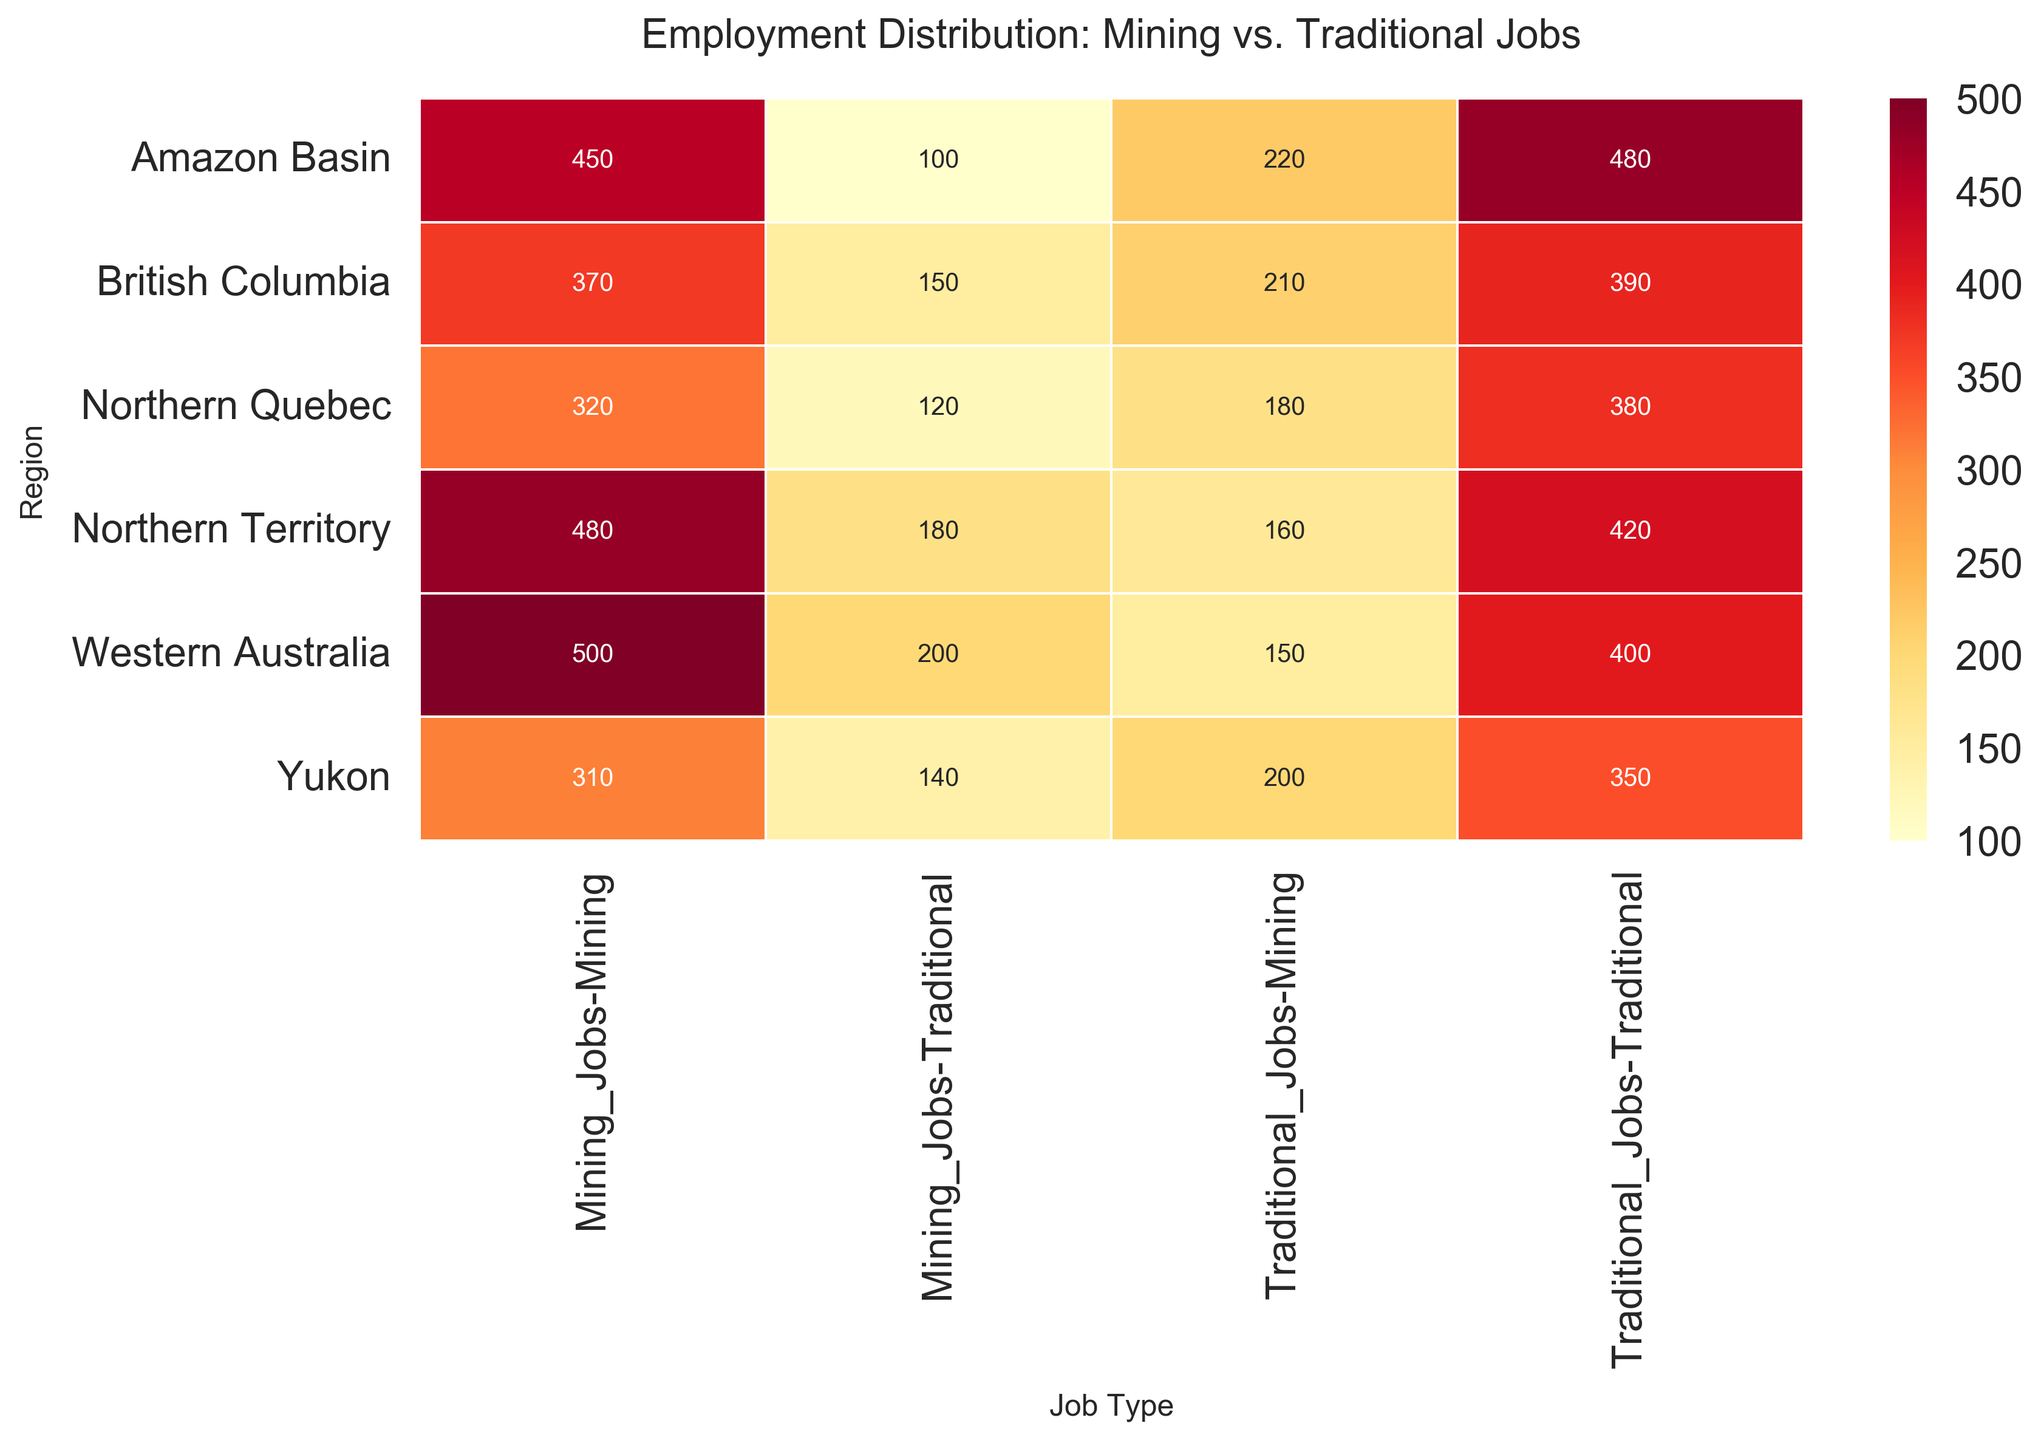What is the title of the heatmap? The title is written at the top of the heatmap.
Answer: Employment Distribution: Mining vs. Traditional Jobs Which region has the highest number of mining jobs? Look at the heatmap's cells in the Mining_Jobs column and identify the one with the highest value.
Answer: Western Australia How many traditional jobs are there in Northern Quebec? Find the cell corresponding to Northern Quebec in the Traditional_Jobs column.
Answer: 380 Compare the number of mining jobs in British Columbia and Northern Territory. Which one has more? Check the values in the Mining_Jobs column for British Columbia and Northern Territory, and compare them.
Answer: Northern Territory What is the total number of traditional jobs in the Amazon Basin and the Yukon? Add the values from the Traditional_Jobs column for the Amazon Basin and the Yukon.
Answer: 830 How does the number of traditional jobs in Northern Quebec compare to mining jobs in the same region? Compare the values in the Traditional_Jobs and Mining_Jobs columns for Northern Quebec.
Answer: Traditional jobs are more What is the average number of mining jobs across all regions? Sum the values in the Mining_Jobs column and divide by the total number of regions to find the average.
Answer: 405 Which region has the fewest traditional jobs, and how many are there? Look at all the values in the Traditional_Jobs column and identify the smallest one.
Answer: Amazon Basin, 100 Is the number of mining jobs generally higher or lower than traditional jobs in these regions? Compare the values across the Mining_Jobs and Traditional_Jobs columns to assess the general trend.
Answer: Generally lower How many regions have more than 300 mining jobs? Count the number of cells in the Mining_Jobs column with values greater than 300.
Answer: 4 